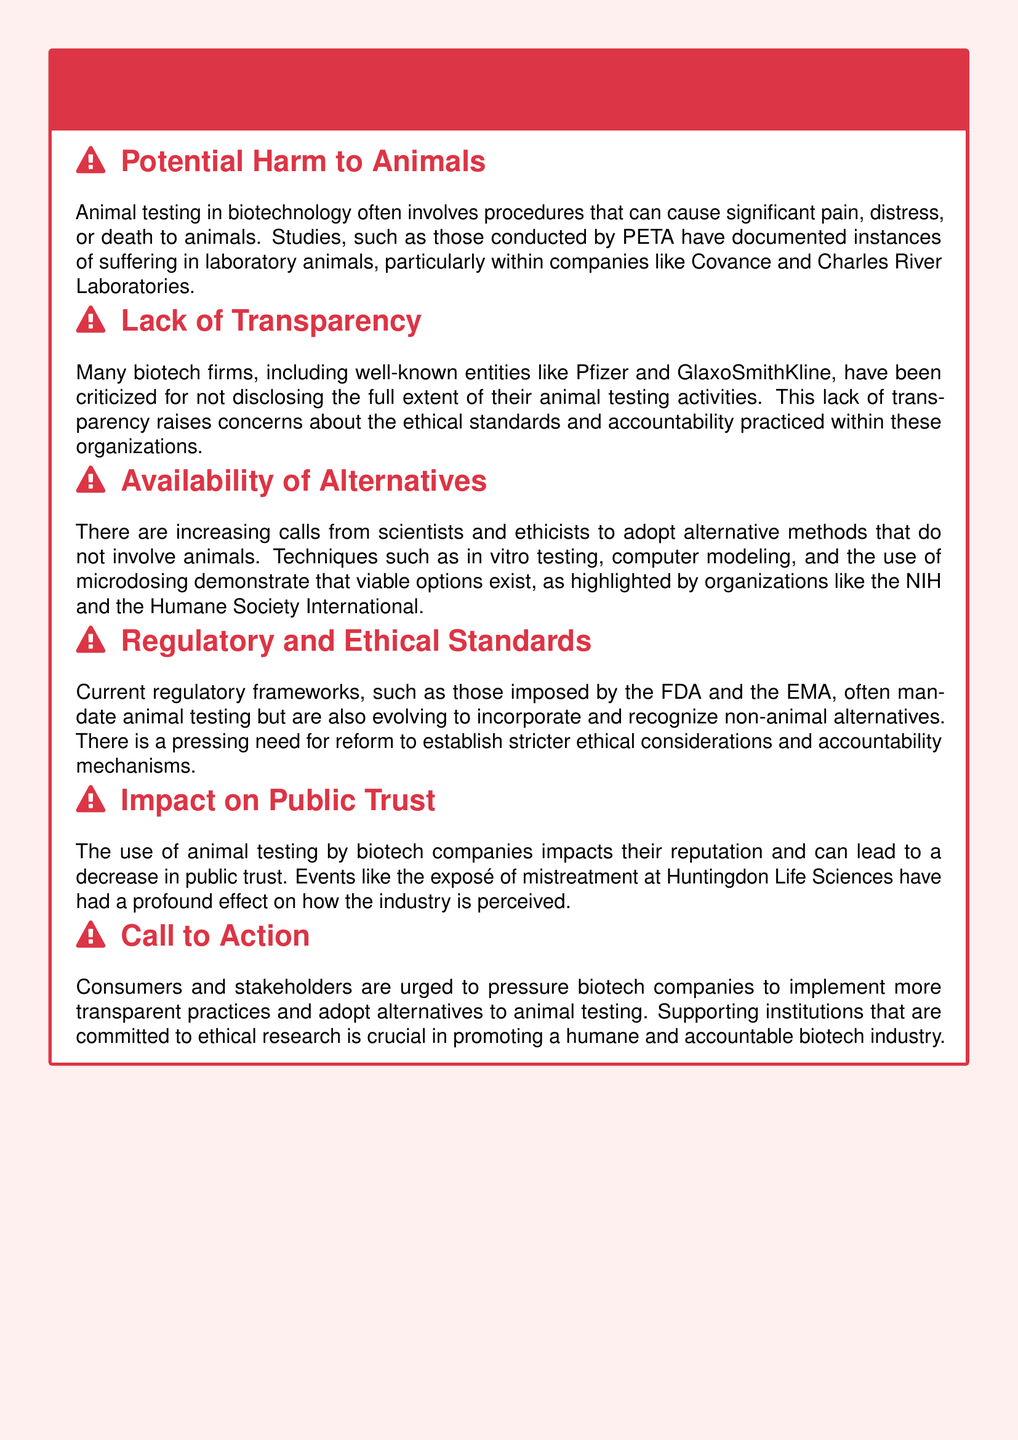What companies are mentioned as having documented instances of suffering in laboratory animals? The companies mentioned are Covance and Charles River Laboratories.
Answer: Covance and Charles River Laboratories Which organizations have highlighted viable alternatives to animal testing? The organizations mentioned are NIH and Humane Society International.
Answer: NIH and Humane Society International What is the primary concern regarding the lack of transparency in biotech firms? The primary concern is about the ethical standards and accountability practiced within these organizations.
Answer: Ethical standards and accountability What impact does animal testing have on biotech companies’ reputation? Animal testing can lead to a decrease in public trust.
Answer: Decrease in public trust Which two regulatory frameworks are mentioned as mandating animal testing? The regulatory frameworks mentioned are FDA and EMA.
Answer: FDA and EMA What is a key call to action from the document? A key call to action is for stakeholders to pressure biotech companies to implement more transparent practices.
Answer: Pressure biotech companies for transparency What type of pain may animals experience during testing? Animals may experience significant pain, distress, or death.
Answer: Significant pain, distress, or death What effect did the exposé of huntingdon life sciences have? The exposé had a profound effect on how the industry is perceived.
Answer: Profound effect on industry perception 